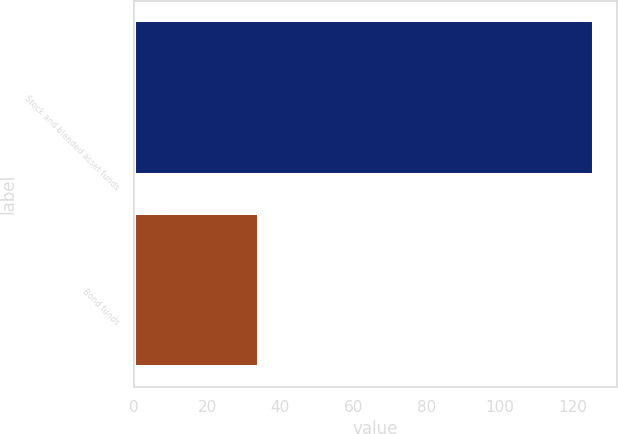Convert chart to OTSL. <chart><loc_0><loc_0><loc_500><loc_500><bar_chart><fcel>Stock and blended asset funds<fcel>Bond funds<nl><fcel>125.7<fcel>34.3<nl></chart> 